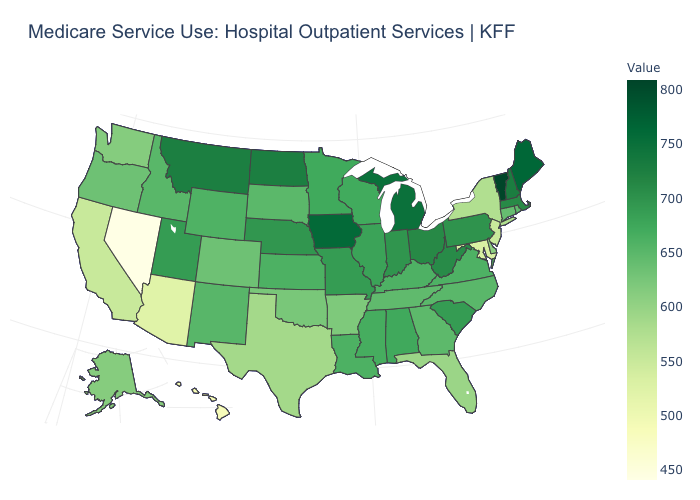Does the map have missing data?
Keep it brief. No. Which states have the lowest value in the MidWest?
Keep it brief. South Dakota. Does Colorado have the lowest value in the USA?
Short answer required. No. Does Tennessee have the lowest value in the USA?
Write a very short answer. No. Does Utah have the highest value in the USA?
Short answer required. No. 